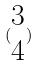Convert formula to latex. <formula><loc_0><loc_0><loc_500><loc_500>( \begin{matrix} 3 \\ 4 \end{matrix} )</formula> 